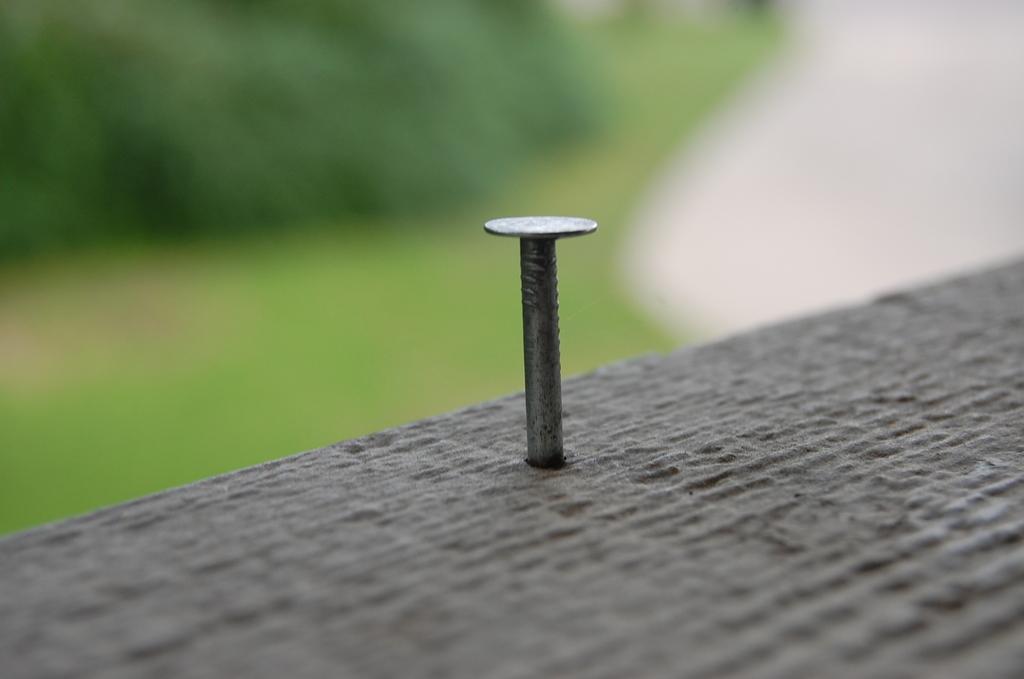Can you describe this image briefly? In this image there is an object having a screw inserted in it. Background is blurry. 